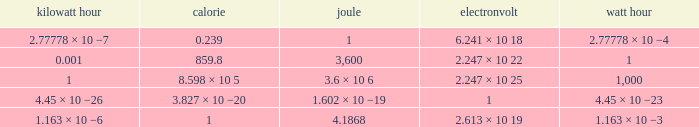How many electronvolts is 3,600 joules? 2.247 × 10 22. 